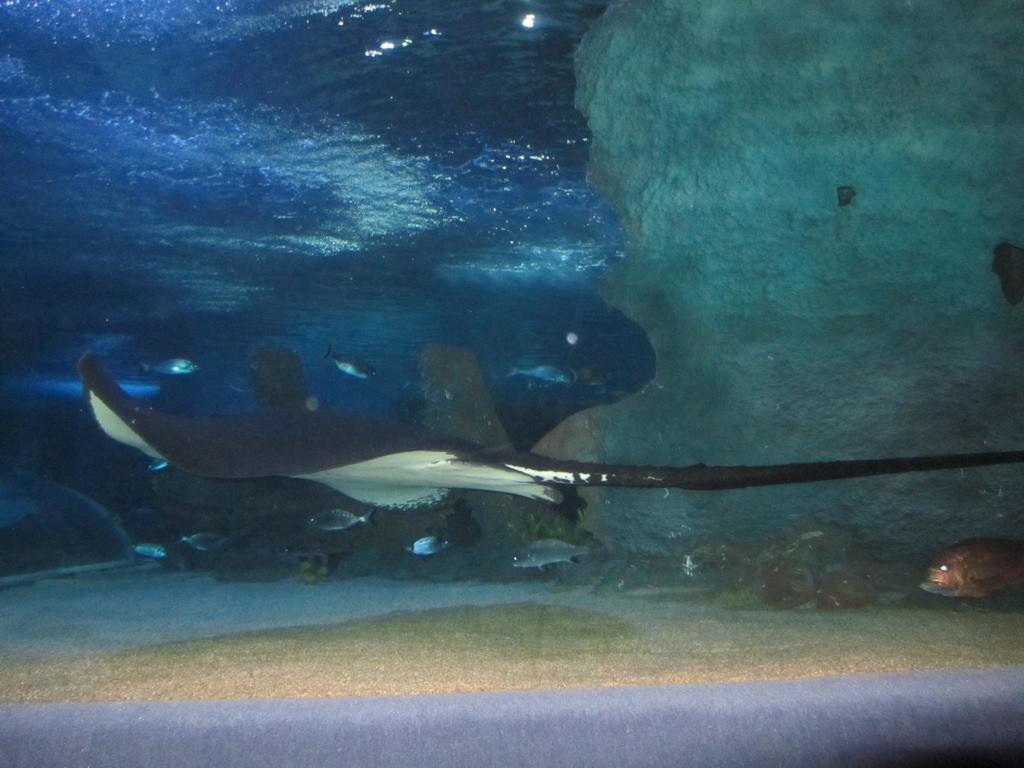What is the main subject in the foreground of the image? There is a stingray in the foreground of the image. What other creatures can be seen in the image? There are many fishes in the image. Where are the fishes located? The fishes are underwater. How many wings can be seen on the stingray in the image? Stingrays do not have wings; they have fins. In the image, you can see the stingray's pectoral fins, which are used for swimming, but they are not wings. 